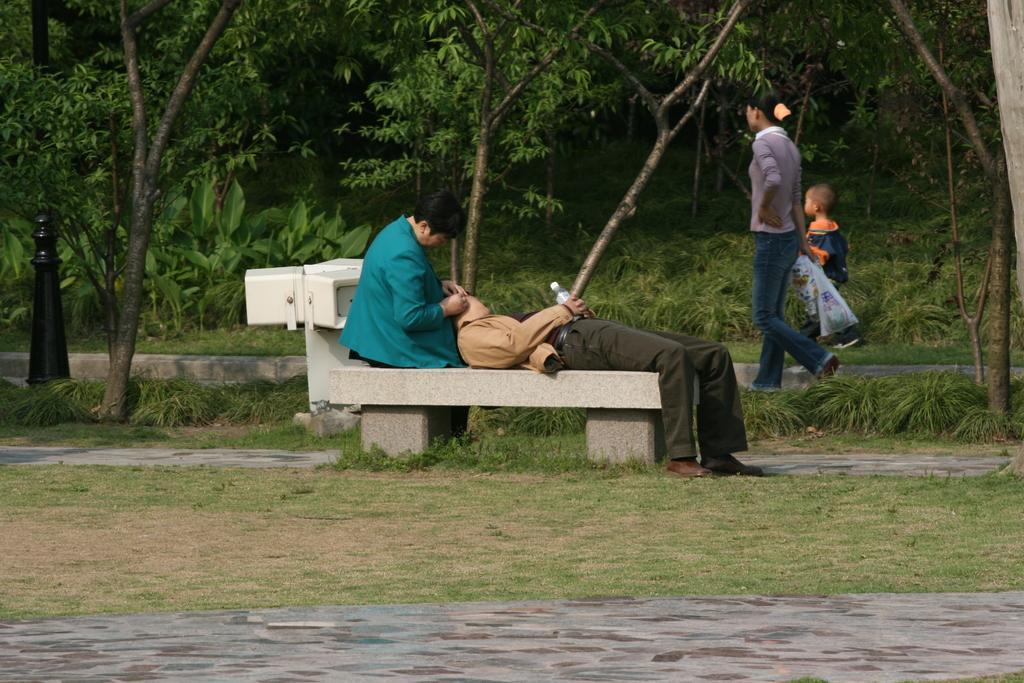Describe this image in one or two sentences. In this image there are three persons and on child. Two person's are siting on the bench. At the back side there are trees. 